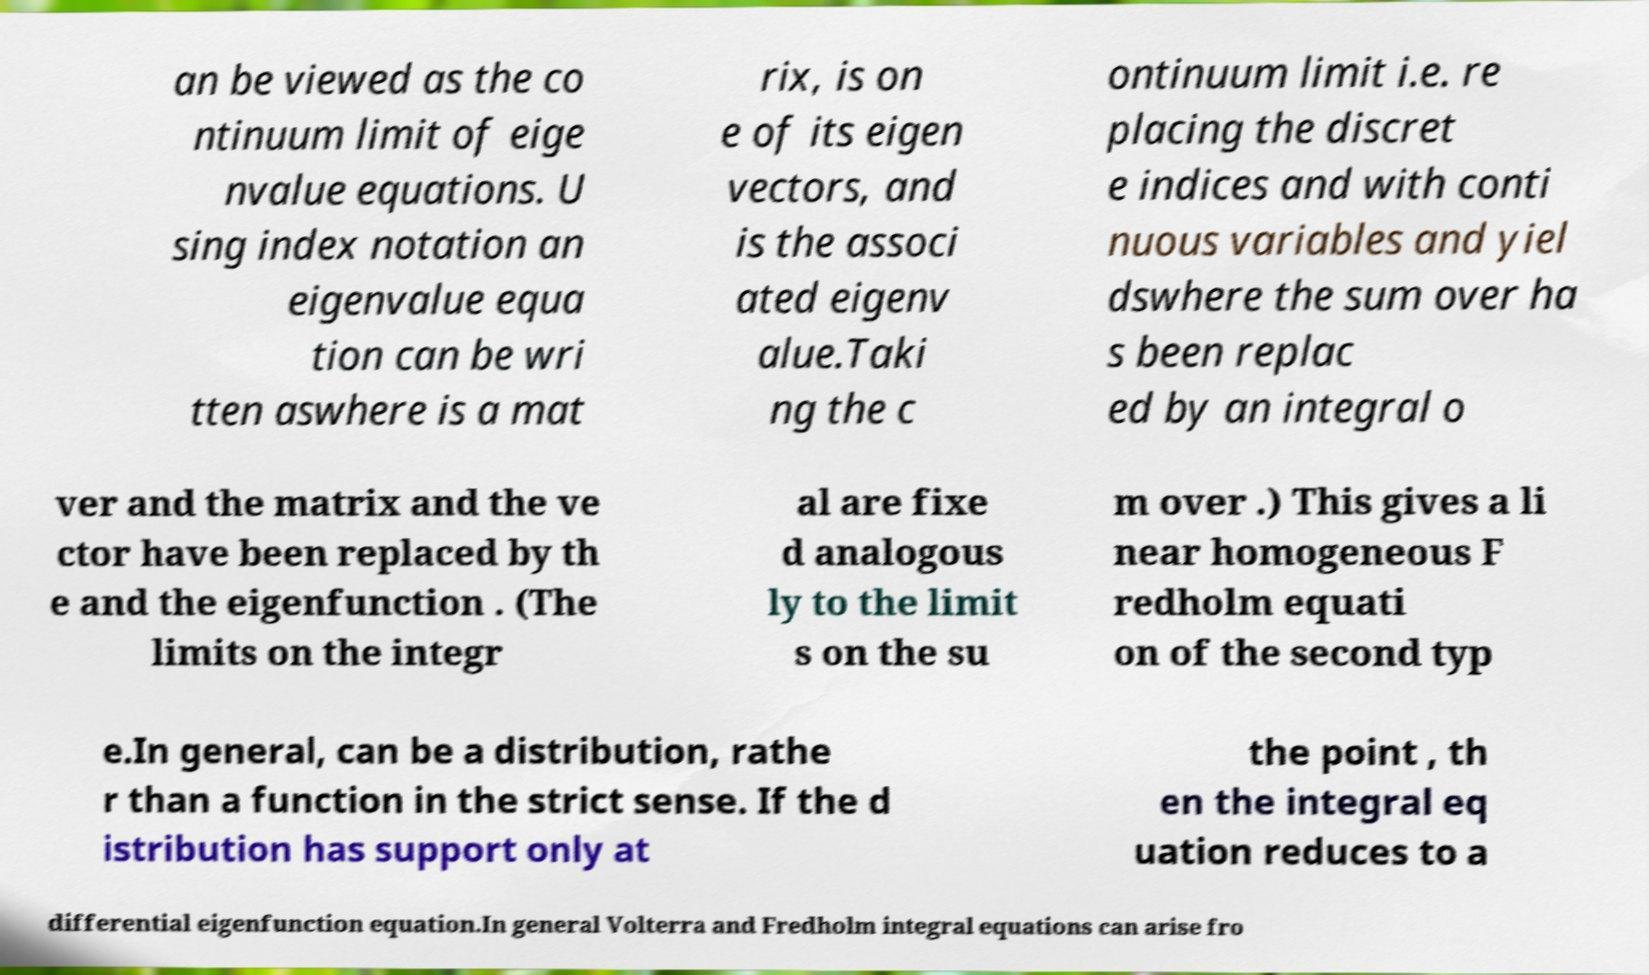There's text embedded in this image that I need extracted. Can you transcribe it verbatim? an be viewed as the co ntinuum limit of eige nvalue equations. U sing index notation an eigenvalue equa tion can be wri tten aswhere is a mat rix, is on e of its eigen vectors, and is the associ ated eigenv alue.Taki ng the c ontinuum limit i.e. re placing the discret e indices and with conti nuous variables and yiel dswhere the sum over ha s been replac ed by an integral o ver and the matrix and the ve ctor have been replaced by th e and the eigenfunction . (The limits on the integr al are fixe d analogous ly to the limit s on the su m over .) This gives a li near homogeneous F redholm equati on of the second typ e.In general, can be a distribution, rathe r than a function in the strict sense. If the d istribution has support only at the point , th en the integral eq uation reduces to a differential eigenfunction equation.In general Volterra and Fredholm integral equations can arise fro 